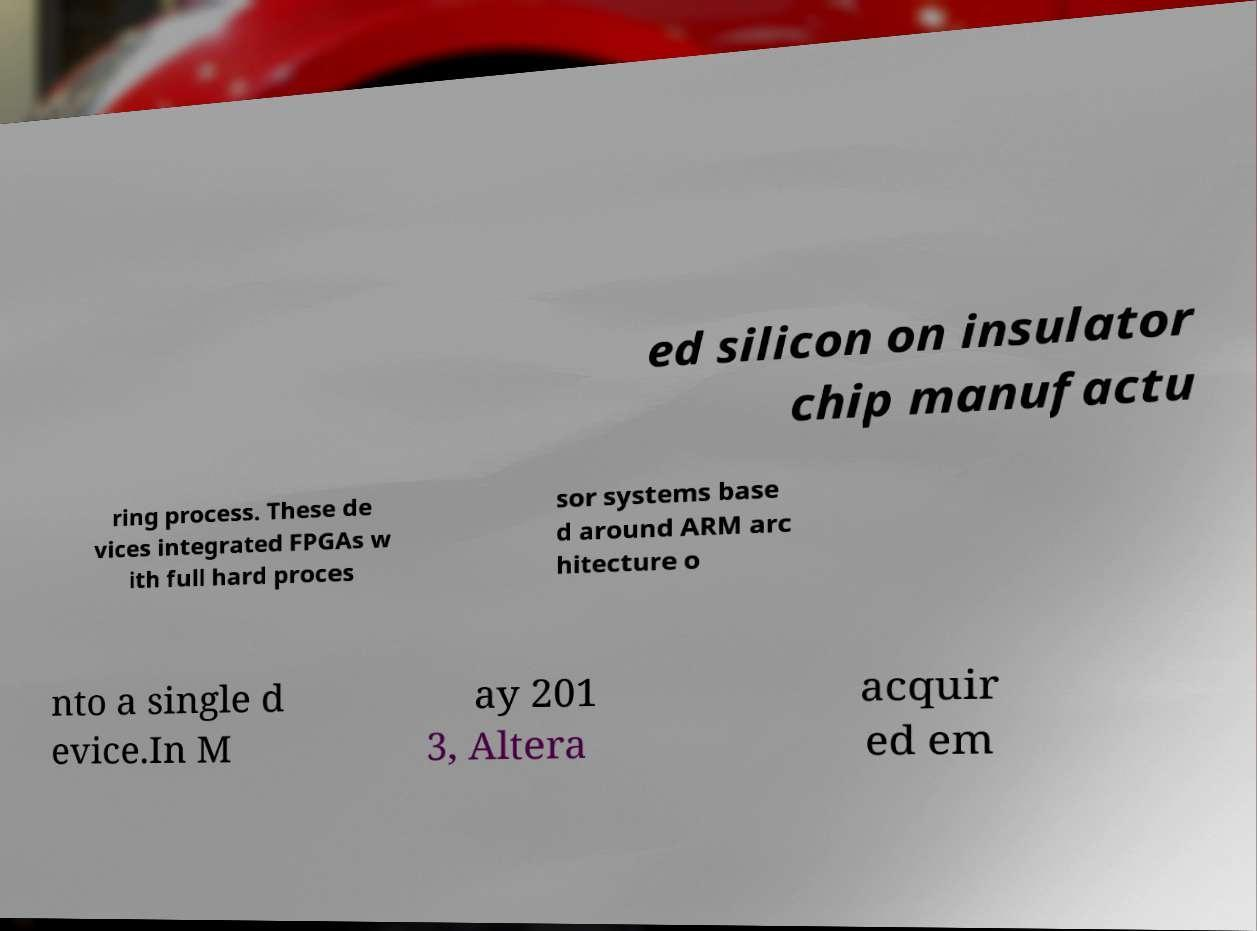Can you accurately transcribe the text from the provided image for me? ed silicon on insulator chip manufactu ring process. These de vices integrated FPGAs w ith full hard proces sor systems base d around ARM arc hitecture o nto a single d evice.In M ay 201 3, Altera acquir ed em 